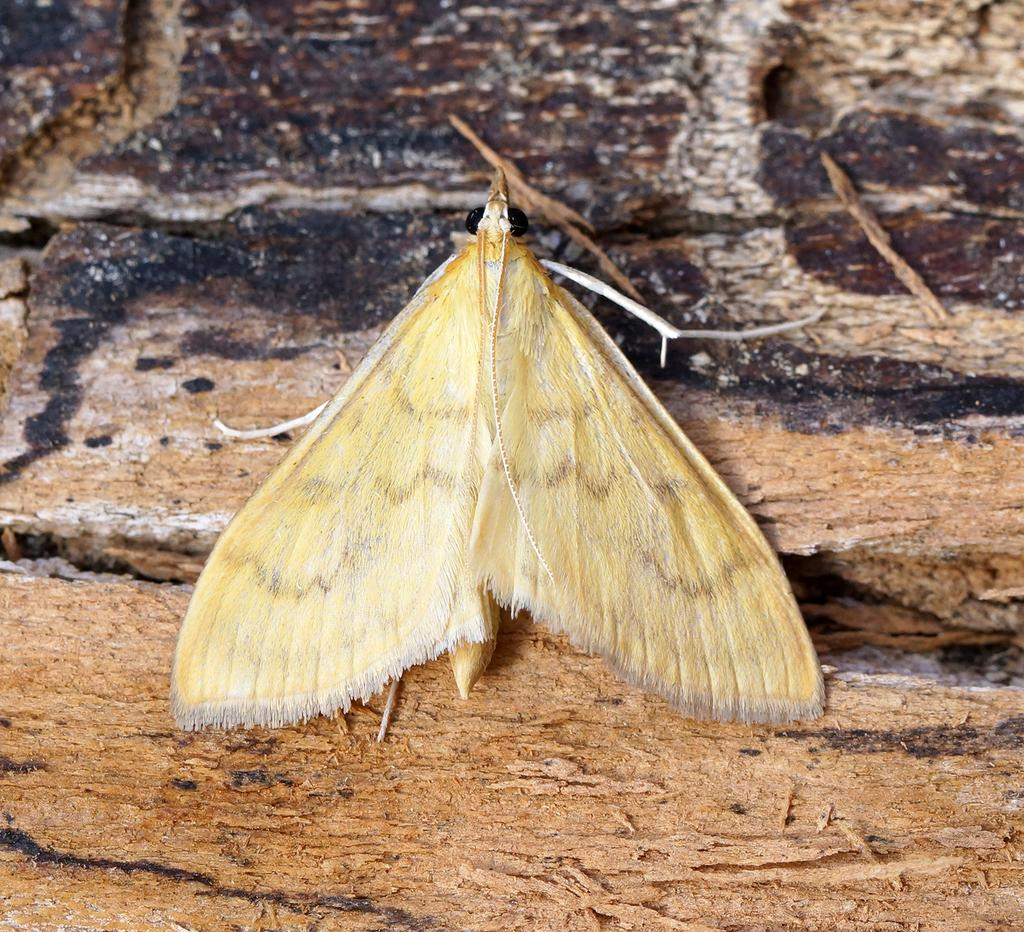What is the main subject of the image? There is a butterfly in the image. Where is the butterfly located? The butterfly is on a table. Can you tell me how many snakes are coiled around the butterfly in the image? There are no snakes present in the image; it features a butterfly on a table. 